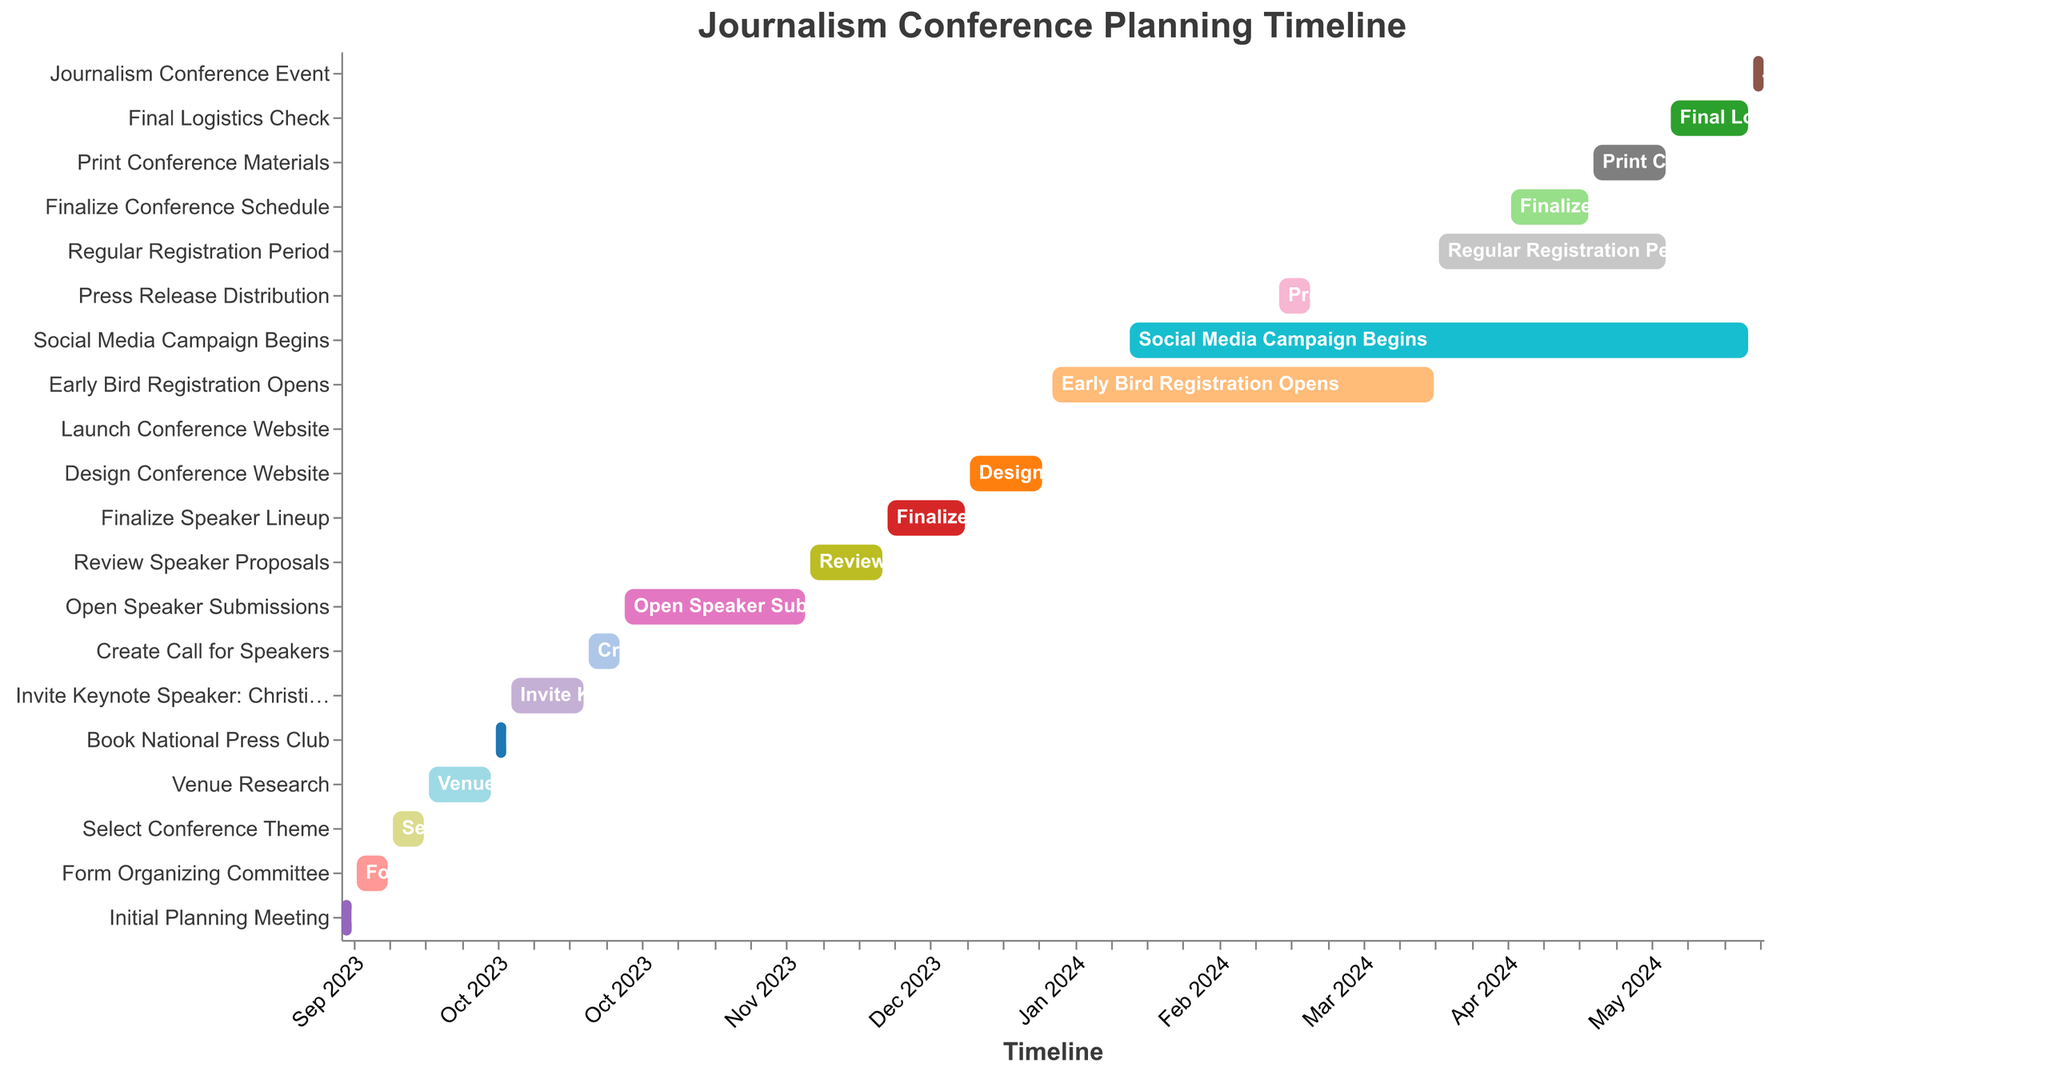What's the title of the Gantt chart? The chart's title is generally placed at the top center and provides an overview of what the chart is about.
Answer: Journalism Conference Planning Timeline When does the "Venue Research" task start and end? Locate the "Venue Research" task on the Gantt chart and check the corresponding start and end dates on the timeline axis.
Answer: Starts: 2023-09-18, Ends: 2023-09-30 Which task starts immediately after "Form Organizing Committee"? Identify the "Form Organizing Committee" task and look for the subsequent task listed directly below it.
Answer: Select Conference Theme How long is the "Early Bird Registration Opens" task? Find the "Early Bird Registration Opens" task and calculate the duration between its start and end dates.
Answer: 74 days How many tasks are scheduled to occur in October 2023? Count all tasks whose start or end dates fall within October 2023.
Answer: 3 tasks Compare the duration of "Invite Keynote Speaker: Christiane Amanpour" and "Open Speaker Submissions", which one is longer? Calculate the duration for both tasks by subtracting the start date from the end date for each and compare the lengths.
Answer: Open Speaker Submissions is longer Which task finishes just before the "Journalism Conference Event"? Look for the task that ends immediately before the start date of the "Journalism Conference Event".
Answer: Final Logistics Check What are the first and last tasks in the Gantt chart? Identify the task that begins earliest and the task that happens last based on their start and end dates.
Answer: First: Initial Planning Meeting, Last: Journalism Conference Event During which months does the "Social Media Campaign Begins" task take place? Observe the start and end dates for "Social Media Campaign Begins" and determine the involved months.
Answer: February 2024 to May 2024 